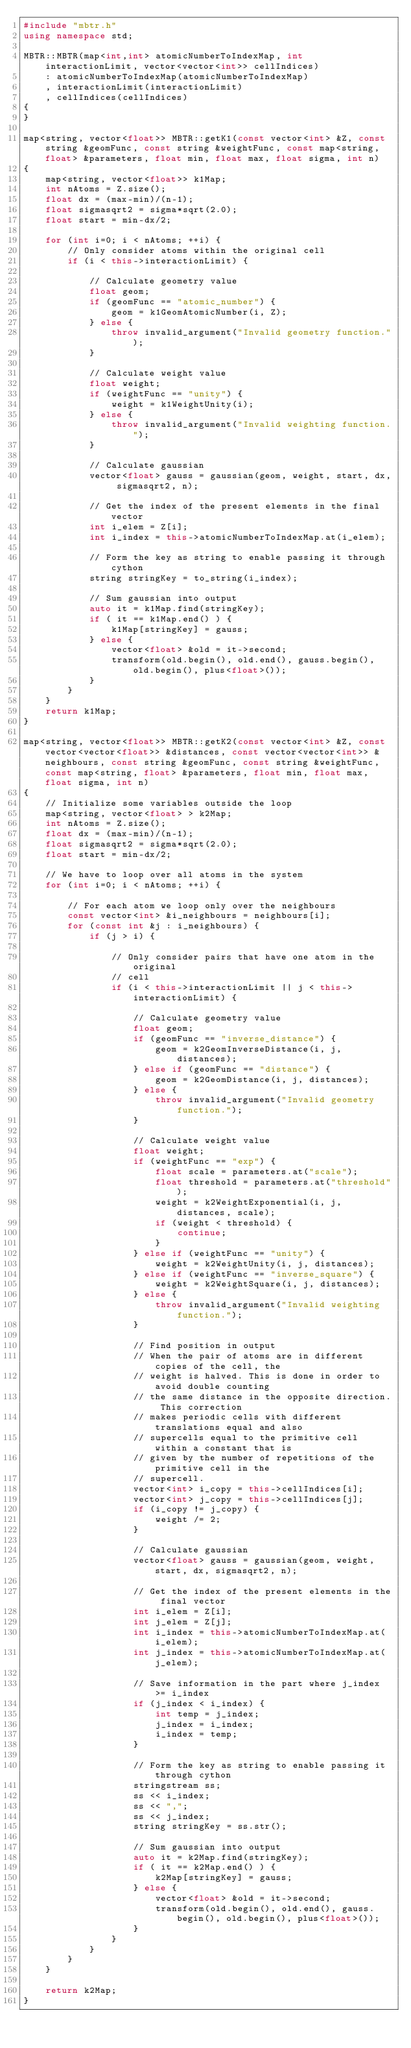Convert code to text. <code><loc_0><loc_0><loc_500><loc_500><_C++_>#include "mbtr.h"
using namespace std;

MBTR::MBTR(map<int,int> atomicNumberToIndexMap, int interactionLimit, vector<vector<int>> cellIndices)
    : atomicNumberToIndexMap(atomicNumberToIndexMap)
    , interactionLimit(interactionLimit)
    , cellIndices(cellIndices)
{
}

map<string, vector<float>> MBTR::getK1(const vector<int> &Z, const string &geomFunc, const string &weightFunc, const map<string, float> &parameters, float min, float max, float sigma, int n)
{
    map<string, vector<float>> k1Map;
    int nAtoms = Z.size();
    float dx = (max-min)/(n-1);
    float sigmasqrt2 = sigma*sqrt(2.0);
    float start = min-dx/2;

    for (int i=0; i < nAtoms; ++i) {
        // Only consider atoms within the original cell
        if (i < this->interactionLimit) {

            // Calculate geometry value
            float geom;
            if (geomFunc == "atomic_number") {
                geom = k1GeomAtomicNumber(i, Z);
            } else {
                throw invalid_argument("Invalid geometry function.");
            }

            // Calculate weight value
            float weight;
            if (weightFunc == "unity") {
                weight = k1WeightUnity(i);
            } else {
                throw invalid_argument("Invalid weighting function.");
            }

            // Calculate gaussian
            vector<float> gauss = gaussian(geom, weight, start, dx, sigmasqrt2, n);

            // Get the index of the present elements in the final vector
            int i_elem = Z[i];
            int i_index = this->atomicNumberToIndexMap.at(i_elem);

            // Form the key as string to enable passing it through cython
            string stringKey = to_string(i_index);

            // Sum gaussian into output
            auto it = k1Map.find(stringKey);
            if ( it == k1Map.end() ) {
                k1Map[stringKey] = gauss;
            } else {
                vector<float> &old = it->second;
                transform(old.begin(), old.end(), gauss.begin(), old.begin(), plus<float>());
            }
        }
    }
    return k1Map;
}

map<string, vector<float>> MBTR::getK2(const vector<int> &Z, const vector<vector<float>> &distances, const vector<vector<int>> &neighbours, const string &geomFunc, const string &weightFunc, const map<string, float> &parameters, float min, float max, float sigma, int n)
{
    // Initialize some variables outside the loop
    map<string, vector<float> > k2Map;
    int nAtoms = Z.size();
    float dx = (max-min)/(n-1);
    float sigmasqrt2 = sigma*sqrt(2.0);
    float start = min-dx/2;

    // We have to loop over all atoms in the system
    for (int i=0; i < nAtoms; ++i) {

        // For each atom we loop only over the neighbours
        const vector<int> &i_neighbours = neighbours[i];
        for (const int &j : i_neighbours) {
            if (j > i) {

                // Only consider pairs that have one atom in the original
                // cell
                if (i < this->interactionLimit || j < this->interactionLimit) {

                    // Calculate geometry value
                    float geom;
                    if (geomFunc == "inverse_distance") {
                        geom = k2GeomInverseDistance(i, j, distances);
                    } else if (geomFunc == "distance") {
                        geom = k2GeomDistance(i, j, distances);
                    } else {
                        throw invalid_argument("Invalid geometry function.");
                    }

                    // Calculate weight value
                    float weight;
                    if (weightFunc == "exp") {
                        float scale = parameters.at("scale");
                        float threshold = parameters.at("threshold");
                        weight = k2WeightExponential(i, j, distances, scale);
                        if (weight < threshold) {
                            continue;
                        }
                    } else if (weightFunc == "unity") {
                        weight = k2WeightUnity(i, j, distances);
                    } else if (weightFunc == "inverse_square") {
                        weight = k2WeightSquare(i, j, distances);
                    } else {
                        throw invalid_argument("Invalid weighting function.");
                    }

                    // Find position in output
                    // When the pair of atoms are in different copies of the cell, the
                    // weight is halved. This is done in order to avoid double counting
                    // the same distance in the opposite direction. This correction
                    // makes periodic cells with different translations equal and also
                    // supercells equal to the primitive cell within a constant that is
                    // given by the number of repetitions of the primitive cell in the
                    // supercell.
                    vector<int> i_copy = this->cellIndices[i];
                    vector<int> j_copy = this->cellIndices[j];
                    if (i_copy != j_copy) {
                        weight /= 2;
                    }

                    // Calculate gaussian
                    vector<float> gauss = gaussian(geom, weight, start, dx, sigmasqrt2, n);

                    // Get the index of the present elements in the final vector
                    int i_elem = Z[i];
                    int j_elem = Z[j];
                    int i_index = this->atomicNumberToIndexMap.at(i_elem);
                    int j_index = this->atomicNumberToIndexMap.at(j_elem);

                    // Save information in the part where j_index >= i_index
                    if (j_index < i_index) {
                        int temp = j_index;
                        j_index = i_index;
                        i_index = temp;
                    }

                    // Form the key as string to enable passing it through cython
                    stringstream ss;
                    ss << i_index;
                    ss << ",";
                    ss << j_index;
                    string stringKey = ss.str();

                    // Sum gaussian into output
                    auto it = k2Map.find(stringKey);
                    if ( it == k2Map.end() ) {
                        k2Map[stringKey] = gauss;
                    } else {
                        vector<float> &old = it->second;
                        transform(old.begin(), old.end(), gauss.begin(), old.begin(), plus<float>());
                    }
                }
            }
        }
    }

    return k2Map;
}
</code> 